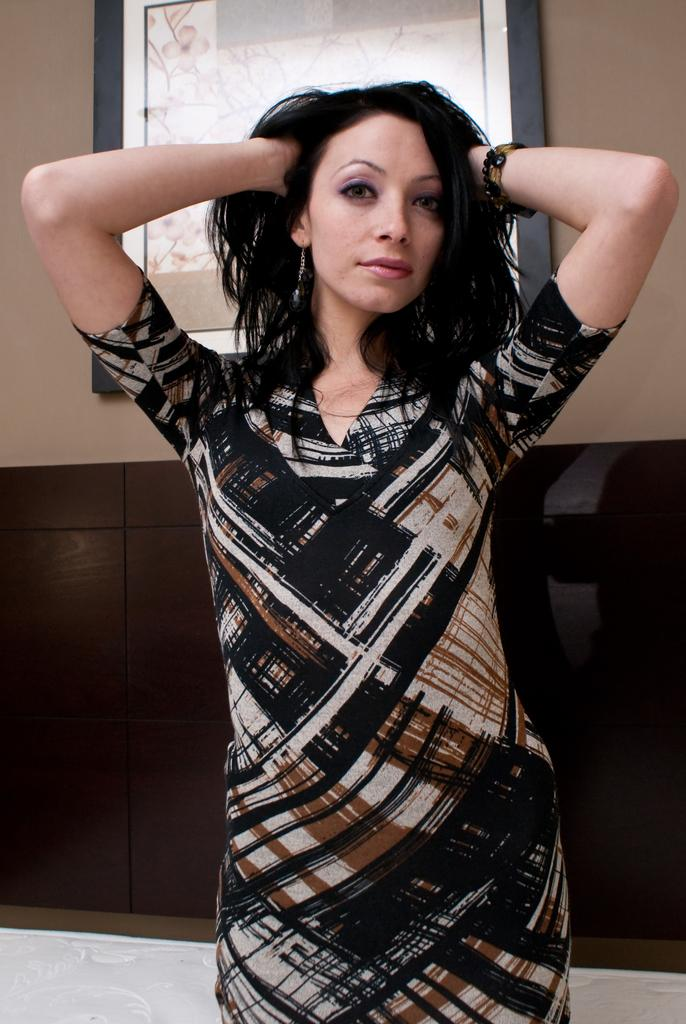What is the main subject of the image? There is a woman standing in the image. Can you describe the background of the image? There is a frame attached to the wall in the background of the image. How many trees are visible in the image? There are no trees visible in the image; it only features a woman standing and a frame on the wall. What type of vase is present on the woman's head in the image? There is no vase present on the woman's head in the image. 